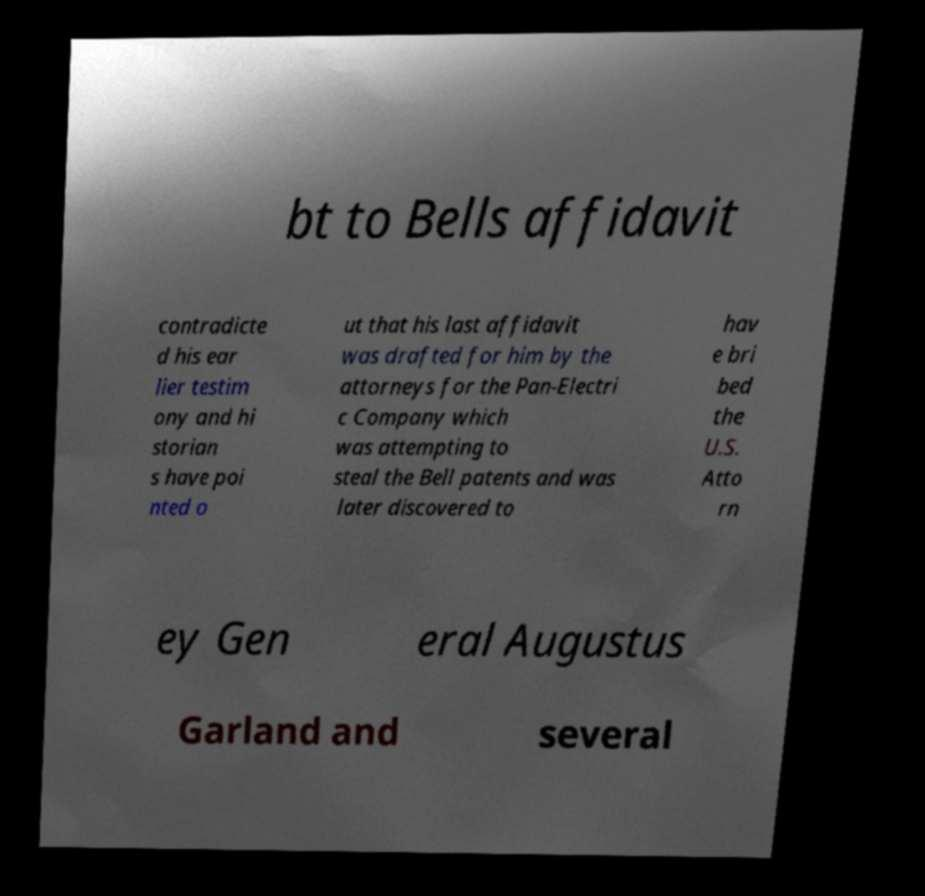What messages or text are displayed in this image? I need them in a readable, typed format. bt to Bells affidavit contradicte d his ear lier testim ony and hi storian s have poi nted o ut that his last affidavit was drafted for him by the attorneys for the Pan-Electri c Company which was attempting to steal the Bell patents and was later discovered to hav e bri bed the U.S. Atto rn ey Gen eral Augustus Garland and several 